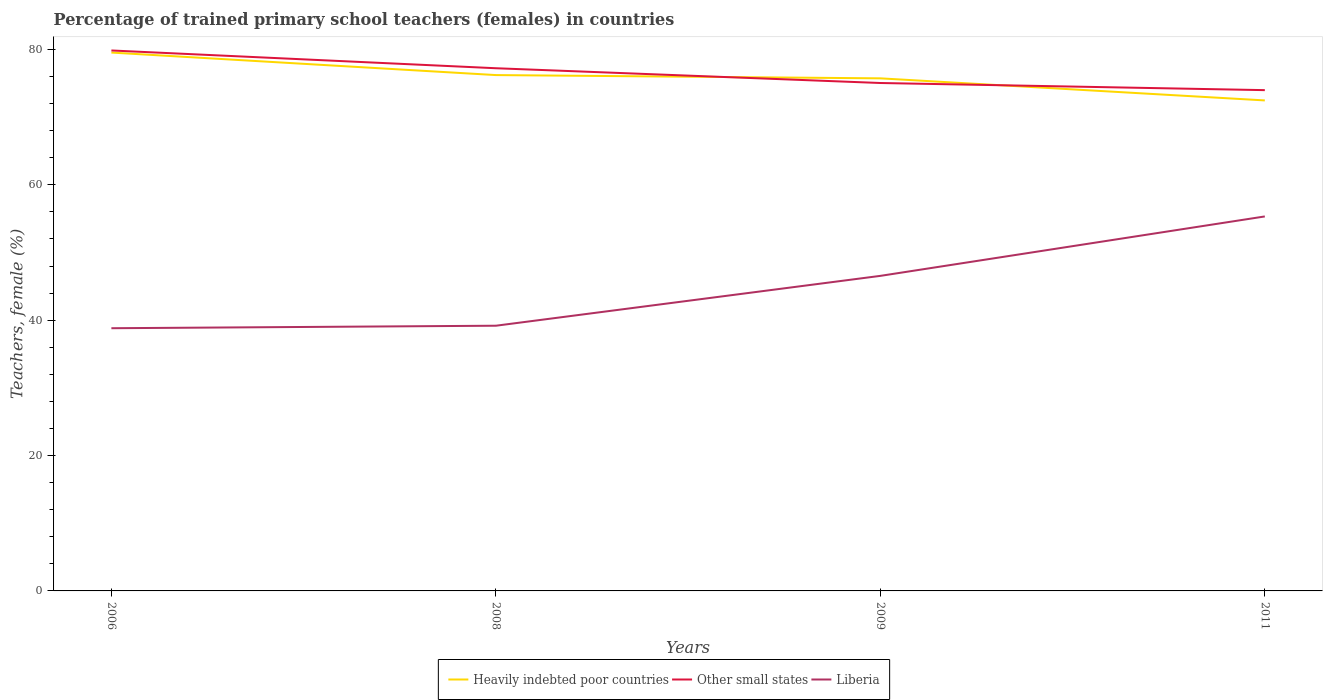Does the line corresponding to Other small states intersect with the line corresponding to Liberia?
Give a very brief answer. No. Across all years, what is the maximum percentage of trained primary school teachers (females) in Other small states?
Provide a short and direct response. 73.98. What is the total percentage of trained primary school teachers (females) in Liberia in the graph?
Your response must be concise. -0.37. What is the difference between the highest and the second highest percentage of trained primary school teachers (females) in Heavily indebted poor countries?
Ensure brevity in your answer.  7.07. What is the difference between the highest and the lowest percentage of trained primary school teachers (females) in Other small states?
Your answer should be compact. 2. Is the percentage of trained primary school teachers (females) in Heavily indebted poor countries strictly greater than the percentage of trained primary school teachers (females) in Liberia over the years?
Your answer should be very brief. No. How many years are there in the graph?
Make the answer very short. 4. Are the values on the major ticks of Y-axis written in scientific E-notation?
Your response must be concise. No. Where does the legend appear in the graph?
Your response must be concise. Bottom center. How many legend labels are there?
Offer a terse response. 3. What is the title of the graph?
Offer a terse response. Percentage of trained primary school teachers (females) in countries. What is the label or title of the X-axis?
Keep it short and to the point. Years. What is the label or title of the Y-axis?
Your answer should be compact. Teachers, female (%). What is the Teachers, female (%) of Heavily indebted poor countries in 2006?
Give a very brief answer. 79.53. What is the Teachers, female (%) in Other small states in 2006?
Your answer should be compact. 79.84. What is the Teachers, female (%) in Liberia in 2006?
Your answer should be very brief. 38.81. What is the Teachers, female (%) of Heavily indebted poor countries in 2008?
Offer a terse response. 76.21. What is the Teachers, female (%) in Other small states in 2008?
Give a very brief answer. 77.22. What is the Teachers, female (%) in Liberia in 2008?
Offer a very short reply. 39.18. What is the Teachers, female (%) of Heavily indebted poor countries in 2009?
Offer a terse response. 75.72. What is the Teachers, female (%) in Other small states in 2009?
Your answer should be very brief. 75.04. What is the Teachers, female (%) of Liberia in 2009?
Your response must be concise. 46.54. What is the Teachers, female (%) in Heavily indebted poor countries in 2011?
Your answer should be compact. 72.46. What is the Teachers, female (%) of Other small states in 2011?
Your response must be concise. 73.98. What is the Teachers, female (%) in Liberia in 2011?
Your answer should be compact. 55.32. Across all years, what is the maximum Teachers, female (%) of Heavily indebted poor countries?
Your answer should be compact. 79.53. Across all years, what is the maximum Teachers, female (%) of Other small states?
Your answer should be compact. 79.84. Across all years, what is the maximum Teachers, female (%) of Liberia?
Provide a short and direct response. 55.32. Across all years, what is the minimum Teachers, female (%) in Heavily indebted poor countries?
Provide a succinct answer. 72.46. Across all years, what is the minimum Teachers, female (%) of Other small states?
Your answer should be very brief. 73.98. Across all years, what is the minimum Teachers, female (%) of Liberia?
Offer a very short reply. 38.81. What is the total Teachers, female (%) of Heavily indebted poor countries in the graph?
Offer a very short reply. 303.93. What is the total Teachers, female (%) of Other small states in the graph?
Provide a succinct answer. 306.08. What is the total Teachers, female (%) of Liberia in the graph?
Your answer should be very brief. 179.86. What is the difference between the Teachers, female (%) of Heavily indebted poor countries in 2006 and that in 2008?
Provide a short and direct response. 3.33. What is the difference between the Teachers, female (%) in Other small states in 2006 and that in 2008?
Provide a succinct answer. 2.63. What is the difference between the Teachers, female (%) of Liberia in 2006 and that in 2008?
Keep it short and to the point. -0.37. What is the difference between the Teachers, female (%) in Heavily indebted poor countries in 2006 and that in 2009?
Offer a very short reply. 3.81. What is the difference between the Teachers, female (%) of Other small states in 2006 and that in 2009?
Make the answer very short. 4.81. What is the difference between the Teachers, female (%) of Liberia in 2006 and that in 2009?
Your answer should be compact. -7.73. What is the difference between the Teachers, female (%) in Heavily indebted poor countries in 2006 and that in 2011?
Your answer should be very brief. 7.07. What is the difference between the Teachers, female (%) in Other small states in 2006 and that in 2011?
Provide a succinct answer. 5.86. What is the difference between the Teachers, female (%) of Liberia in 2006 and that in 2011?
Give a very brief answer. -16.51. What is the difference between the Teachers, female (%) of Heavily indebted poor countries in 2008 and that in 2009?
Keep it short and to the point. 0.48. What is the difference between the Teachers, female (%) of Other small states in 2008 and that in 2009?
Keep it short and to the point. 2.18. What is the difference between the Teachers, female (%) in Liberia in 2008 and that in 2009?
Your response must be concise. -7.37. What is the difference between the Teachers, female (%) in Heavily indebted poor countries in 2008 and that in 2011?
Provide a succinct answer. 3.74. What is the difference between the Teachers, female (%) in Other small states in 2008 and that in 2011?
Your response must be concise. 3.23. What is the difference between the Teachers, female (%) in Liberia in 2008 and that in 2011?
Give a very brief answer. -16.14. What is the difference between the Teachers, female (%) in Heavily indebted poor countries in 2009 and that in 2011?
Ensure brevity in your answer.  3.26. What is the difference between the Teachers, female (%) of Other small states in 2009 and that in 2011?
Provide a succinct answer. 1.05. What is the difference between the Teachers, female (%) in Liberia in 2009 and that in 2011?
Keep it short and to the point. -8.78. What is the difference between the Teachers, female (%) of Heavily indebted poor countries in 2006 and the Teachers, female (%) of Other small states in 2008?
Your answer should be very brief. 2.32. What is the difference between the Teachers, female (%) in Heavily indebted poor countries in 2006 and the Teachers, female (%) in Liberia in 2008?
Provide a succinct answer. 40.35. What is the difference between the Teachers, female (%) of Other small states in 2006 and the Teachers, female (%) of Liberia in 2008?
Offer a terse response. 40.66. What is the difference between the Teachers, female (%) in Heavily indebted poor countries in 2006 and the Teachers, female (%) in Other small states in 2009?
Give a very brief answer. 4.5. What is the difference between the Teachers, female (%) in Heavily indebted poor countries in 2006 and the Teachers, female (%) in Liberia in 2009?
Make the answer very short. 32.99. What is the difference between the Teachers, female (%) in Other small states in 2006 and the Teachers, female (%) in Liberia in 2009?
Give a very brief answer. 33.3. What is the difference between the Teachers, female (%) in Heavily indebted poor countries in 2006 and the Teachers, female (%) in Other small states in 2011?
Offer a terse response. 5.55. What is the difference between the Teachers, female (%) of Heavily indebted poor countries in 2006 and the Teachers, female (%) of Liberia in 2011?
Your answer should be very brief. 24.21. What is the difference between the Teachers, female (%) of Other small states in 2006 and the Teachers, female (%) of Liberia in 2011?
Your answer should be compact. 24.52. What is the difference between the Teachers, female (%) of Heavily indebted poor countries in 2008 and the Teachers, female (%) of Other small states in 2009?
Offer a terse response. 1.17. What is the difference between the Teachers, female (%) of Heavily indebted poor countries in 2008 and the Teachers, female (%) of Liberia in 2009?
Keep it short and to the point. 29.66. What is the difference between the Teachers, female (%) of Other small states in 2008 and the Teachers, female (%) of Liberia in 2009?
Keep it short and to the point. 30.67. What is the difference between the Teachers, female (%) in Heavily indebted poor countries in 2008 and the Teachers, female (%) in Other small states in 2011?
Offer a very short reply. 2.22. What is the difference between the Teachers, female (%) in Heavily indebted poor countries in 2008 and the Teachers, female (%) in Liberia in 2011?
Ensure brevity in your answer.  20.88. What is the difference between the Teachers, female (%) of Other small states in 2008 and the Teachers, female (%) of Liberia in 2011?
Ensure brevity in your answer.  21.89. What is the difference between the Teachers, female (%) of Heavily indebted poor countries in 2009 and the Teachers, female (%) of Other small states in 2011?
Provide a short and direct response. 1.74. What is the difference between the Teachers, female (%) of Heavily indebted poor countries in 2009 and the Teachers, female (%) of Liberia in 2011?
Your answer should be very brief. 20.4. What is the difference between the Teachers, female (%) in Other small states in 2009 and the Teachers, female (%) in Liberia in 2011?
Offer a terse response. 19.71. What is the average Teachers, female (%) of Heavily indebted poor countries per year?
Make the answer very short. 75.98. What is the average Teachers, female (%) of Other small states per year?
Your answer should be very brief. 76.52. What is the average Teachers, female (%) in Liberia per year?
Provide a succinct answer. 44.96. In the year 2006, what is the difference between the Teachers, female (%) in Heavily indebted poor countries and Teachers, female (%) in Other small states?
Offer a very short reply. -0.31. In the year 2006, what is the difference between the Teachers, female (%) of Heavily indebted poor countries and Teachers, female (%) of Liberia?
Offer a very short reply. 40.72. In the year 2006, what is the difference between the Teachers, female (%) of Other small states and Teachers, female (%) of Liberia?
Offer a very short reply. 41.03. In the year 2008, what is the difference between the Teachers, female (%) in Heavily indebted poor countries and Teachers, female (%) in Other small states?
Your answer should be compact. -1.01. In the year 2008, what is the difference between the Teachers, female (%) of Heavily indebted poor countries and Teachers, female (%) of Liberia?
Offer a terse response. 37.03. In the year 2008, what is the difference between the Teachers, female (%) in Other small states and Teachers, female (%) in Liberia?
Provide a succinct answer. 38.04. In the year 2009, what is the difference between the Teachers, female (%) in Heavily indebted poor countries and Teachers, female (%) in Other small states?
Your answer should be very brief. 0.69. In the year 2009, what is the difference between the Teachers, female (%) in Heavily indebted poor countries and Teachers, female (%) in Liberia?
Your answer should be compact. 29.18. In the year 2009, what is the difference between the Teachers, female (%) of Other small states and Teachers, female (%) of Liberia?
Your answer should be compact. 28.49. In the year 2011, what is the difference between the Teachers, female (%) in Heavily indebted poor countries and Teachers, female (%) in Other small states?
Offer a terse response. -1.52. In the year 2011, what is the difference between the Teachers, female (%) of Heavily indebted poor countries and Teachers, female (%) of Liberia?
Keep it short and to the point. 17.14. In the year 2011, what is the difference between the Teachers, female (%) of Other small states and Teachers, female (%) of Liberia?
Offer a terse response. 18.66. What is the ratio of the Teachers, female (%) of Heavily indebted poor countries in 2006 to that in 2008?
Your response must be concise. 1.04. What is the ratio of the Teachers, female (%) of Other small states in 2006 to that in 2008?
Provide a short and direct response. 1.03. What is the ratio of the Teachers, female (%) in Liberia in 2006 to that in 2008?
Your answer should be very brief. 0.99. What is the ratio of the Teachers, female (%) in Heavily indebted poor countries in 2006 to that in 2009?
Offer a terse response. 1.05. What is the ratio of the Teachers, female (%) in Other small states in 2006 to that in 2009?
Keep it short and to the point. 1.06. What is the ratio of the Teachers, female (%) in Liberia in 2006 to that in 2009?
Make the answer very short. 0.83. What is the ratio of the Teachers, female (%) of Heavily indebted poor countries in 2006 to that in 2011?
Your response must be concise. 1.1. What is the ratio of the Teachers, female (%) in Other small states in 2006 to that in 2011?
Your answer should be very brief. 1.08. What is the ratio of the Teachers, female (%) in Liberia in 2006 to that in 2011?
Provide a succinct answer. 0.7. What is the ratio of the Teachers, female (%) of Heavily indebted poor countries in 2008 to that in 2009?
Ensure brevity in your answer.  1.01. What is the ratio of the Teachers, female (%) of Other small states in 2008 to that in 2009?
Your answer should be compact. 1.03. What is the ratio of the Teachers, female (%) in Liberia in 2008 to that in 2009?
Provide a succinct answer. 0.84. What is the ratio of the Teachers, female (%) in Heavily indebted poor countries in 2008 to that in 2011?
Provide a short and direct response. 1.05. What is the ratio of the Teachers, female (%) of Other small states in 2008 to that in 2011?
Give a very brief answer. 1.04. What is the ratio of the Teachers, female (%) of Liberia in 2008 to that in 2011?
Your answer should be very brief. 0.71. What is the ratio of the Teachers, female (%) in Heavily indebted poor countries in 2009 to that in 2011?
Ensure brevity in your answer.  1.04. What is the ratio of the Teachers, female (%) of Other small states in 2009 to that in 2011?
Offer a very short reply. 1.01. What is the ratio of the Teachers, female (%) of Liberia in 2009 to that in 2011?
Provide a succinct answer. 0.84. What is the difference between the highest and the second highest Teachers, female (%) in Heavily indebted poor countries?
Your response must be concise. 3.33. What is the difference between the highest and the second highest Teachers, female (%) in Other small states?
Keep it short and to the point. 2.63. What is the difference between the highest and the second highest Teachers, female (%) of Liberia?
Your response must be concise. 8.78. What is the difference between the highest and the lowest Teachers, female (%) of Heavily indebted poor countries?
Keep it short and to the point. 7.07. What is the difference between the highest and the lowest Teachers, female (%) in Other small states?
Your answer should be very brief. 5.86. What is the difference between the highest and the lowest Teachers, female (%) in Liberia?
Keep it short and to the point. 16.51. 